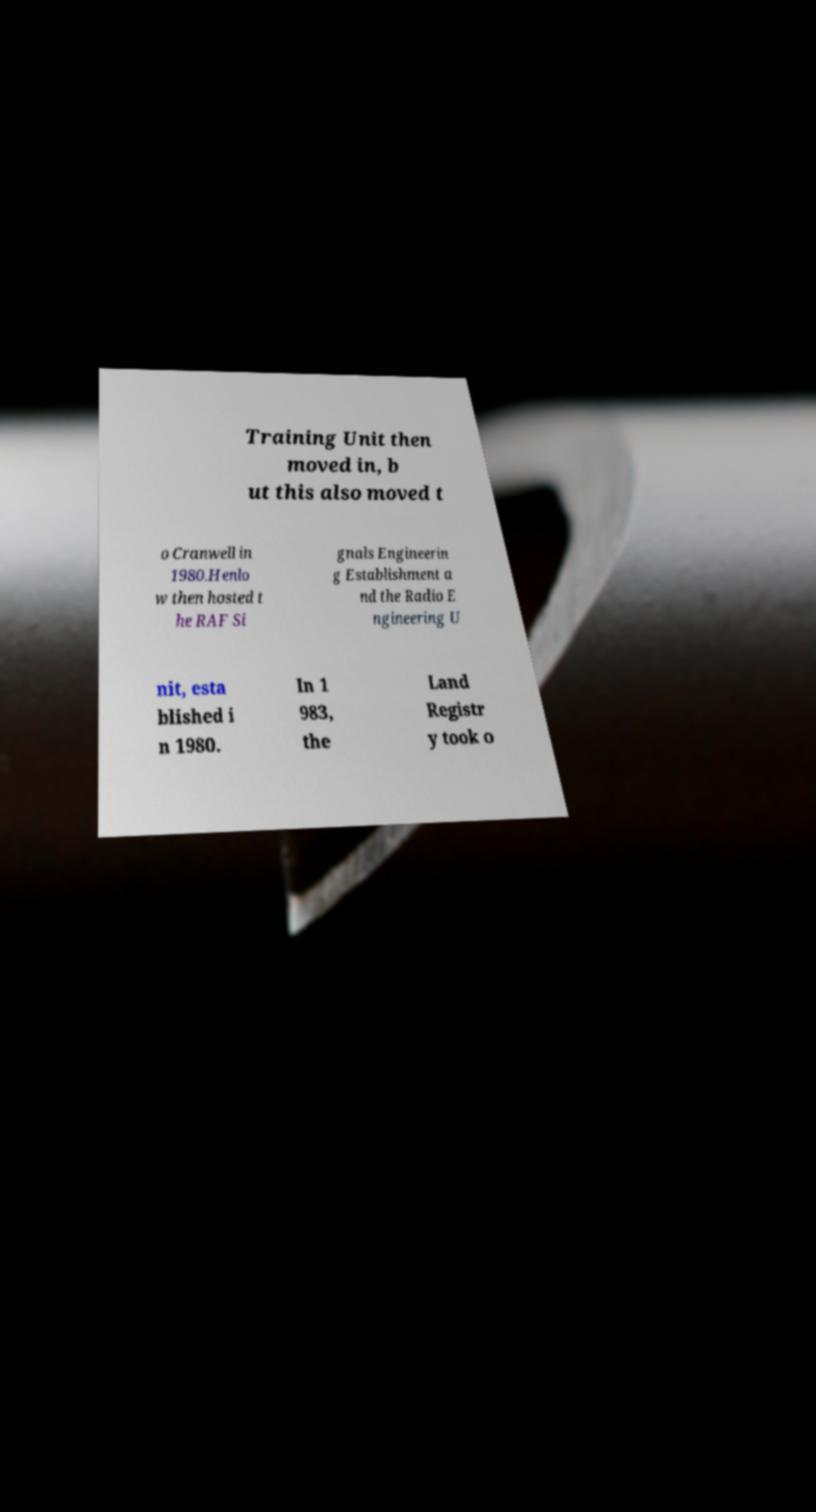Please identify and transcribe the text found in this image. Training Unit then moved in, b ut this also moved t o Cranwell in 1980.Henlo w then hosted t he RAF Si gnals Engineerin g Establishment a nd the Radio E ngineering U nit, esta blished i n 1980. In 1 983, the Land Registr y took o 